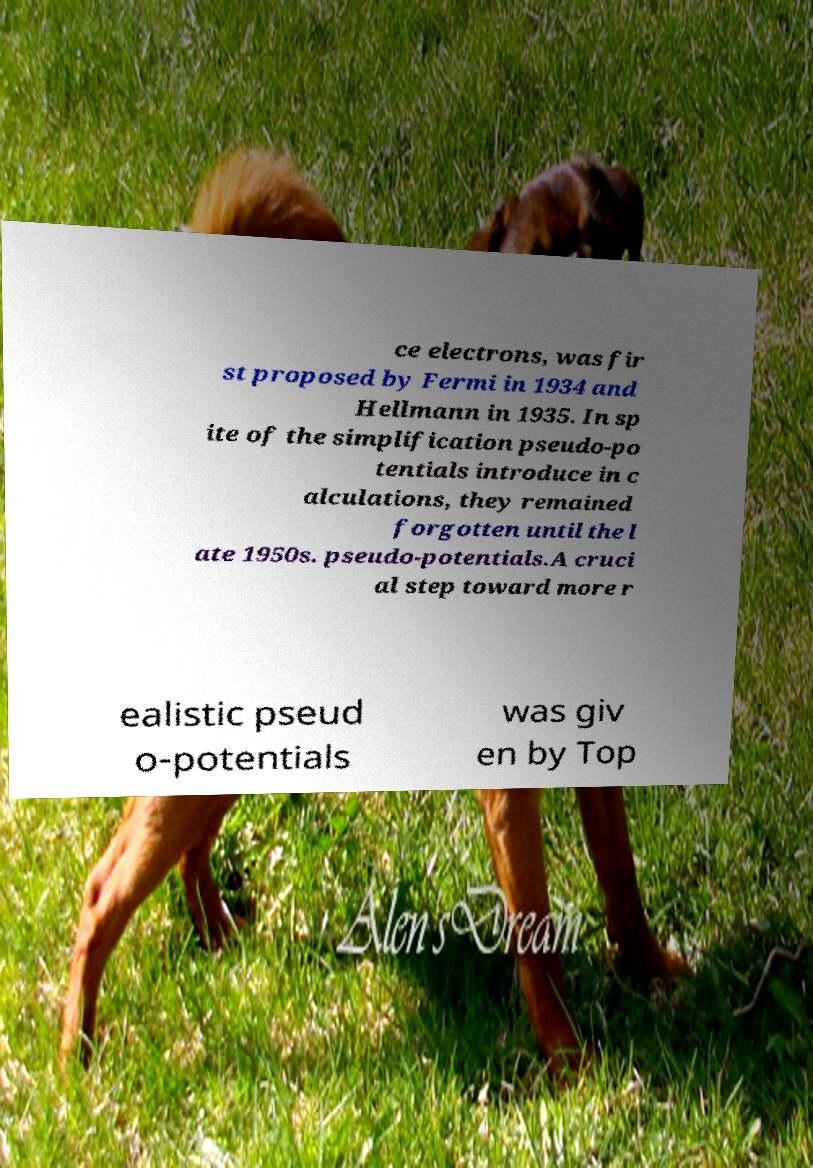Could you assist in decoding the text presented in this image and type it out clearly? ce electrons, was fir st proposed by Fermi in 1934 and Hellmann in 1935. In sp ite of the simplification pseudo-po tentials introduce in c alculations, they remained forgotten until the l ate 1950s. pseudo-potentials.A cruci al step toward more r ealistic pseud o-potentials was giv en by Top 